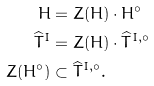<formula> <loc_0><loc_0><loc_500><loc_500>H & = Z ( H ) \cdot H ^ { \circ } \\ \widehat { T } ^ { I } & = Z ( H ) \cdot \widehat { T } ^ { I , \circ } \\ Z ( H ^ { \circ } ) & \subset \widehat { T } ^ { I , \circ } .</formula> 